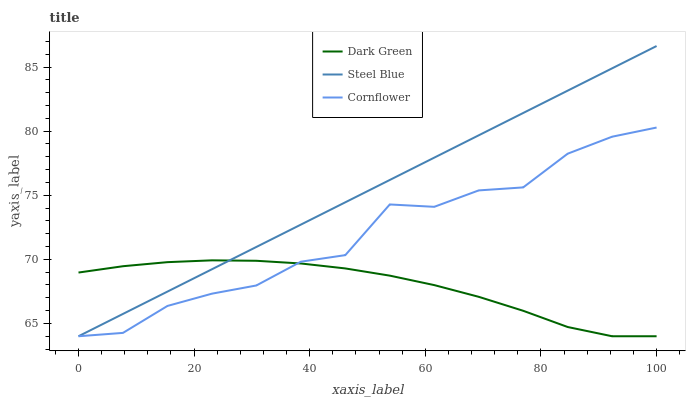Does Steel Blue have the minimum area under the curve?
Answer yes or no. No. Does Dark Green have the maximum area under the curve?
Answer yes or no. No. Is Dark Green the smoothest?
Answer yes or no. No. Is Dark Green the roughest?
Answer yes or no. No. Does Dark Green have the highest value?
Answer yes or no. No. 